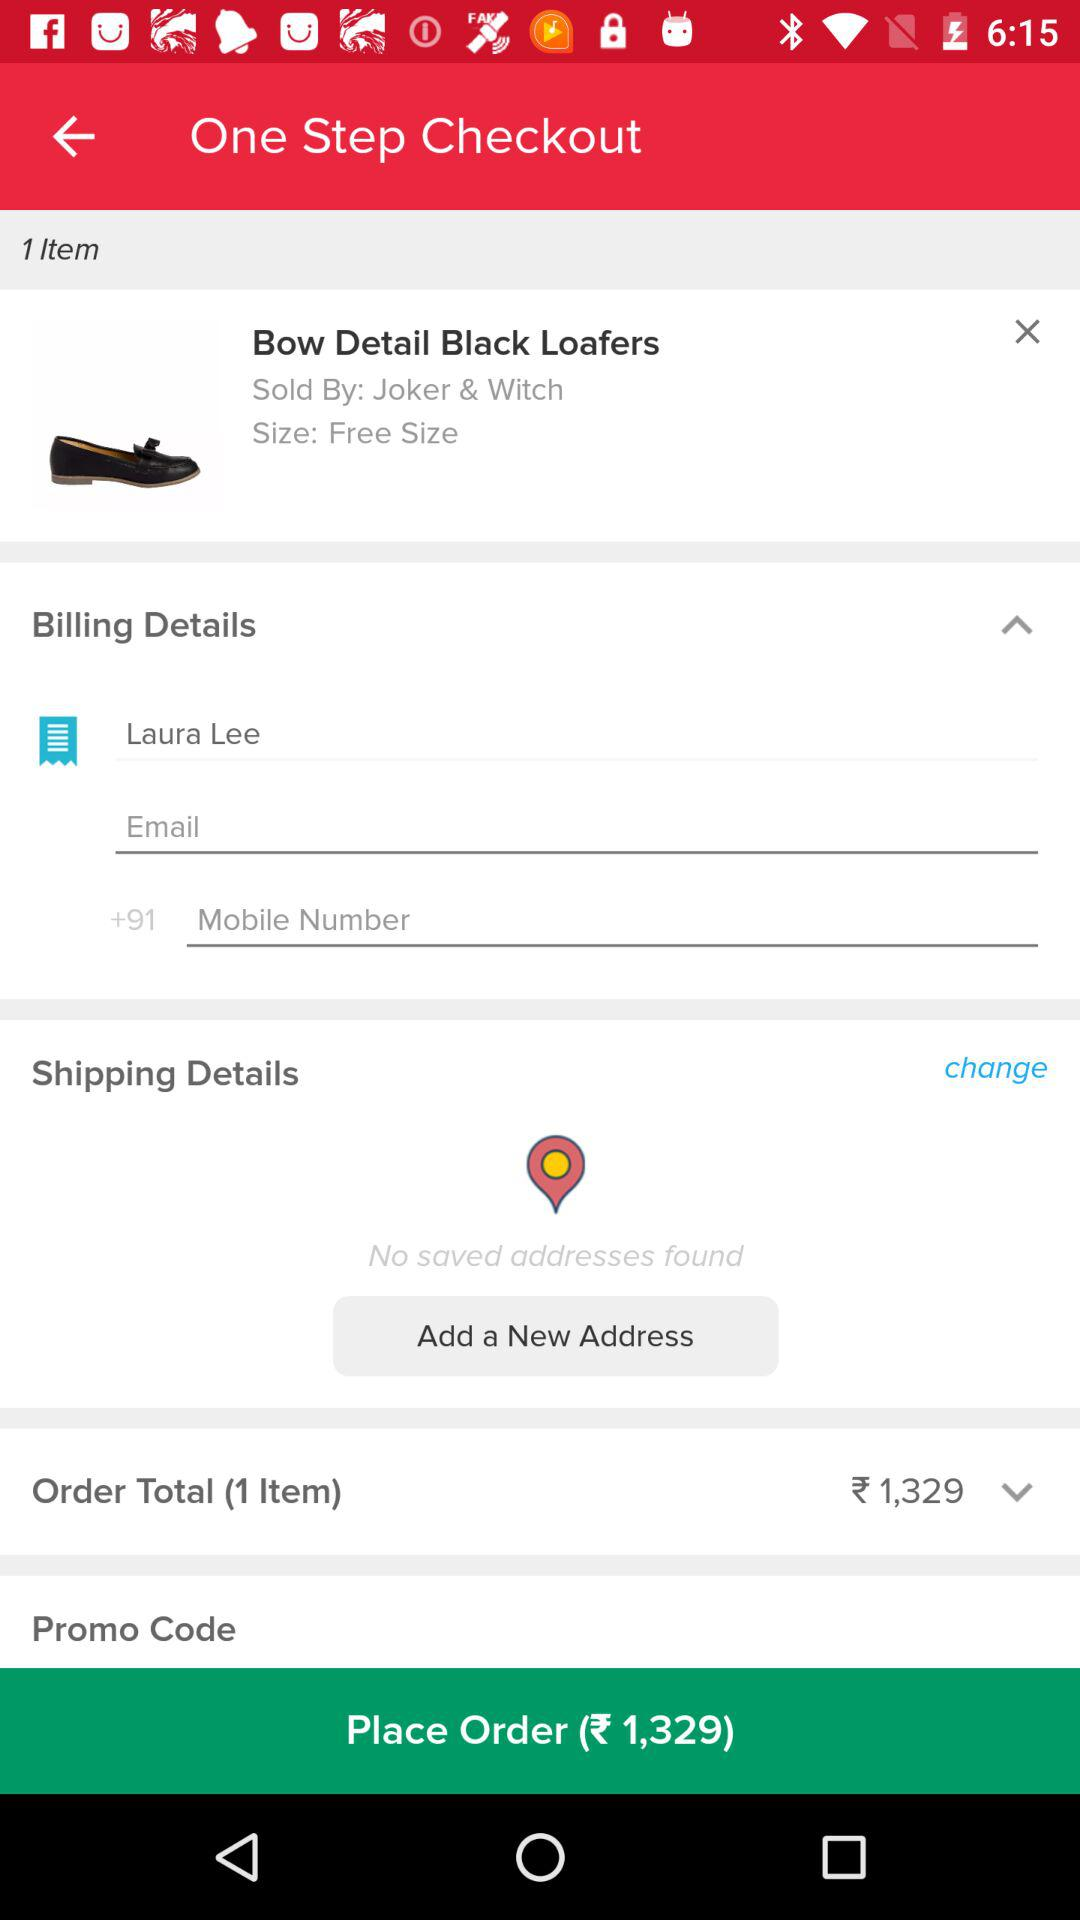Whose name is in the billing details? The name that is in the billing details is Laura Lee. 